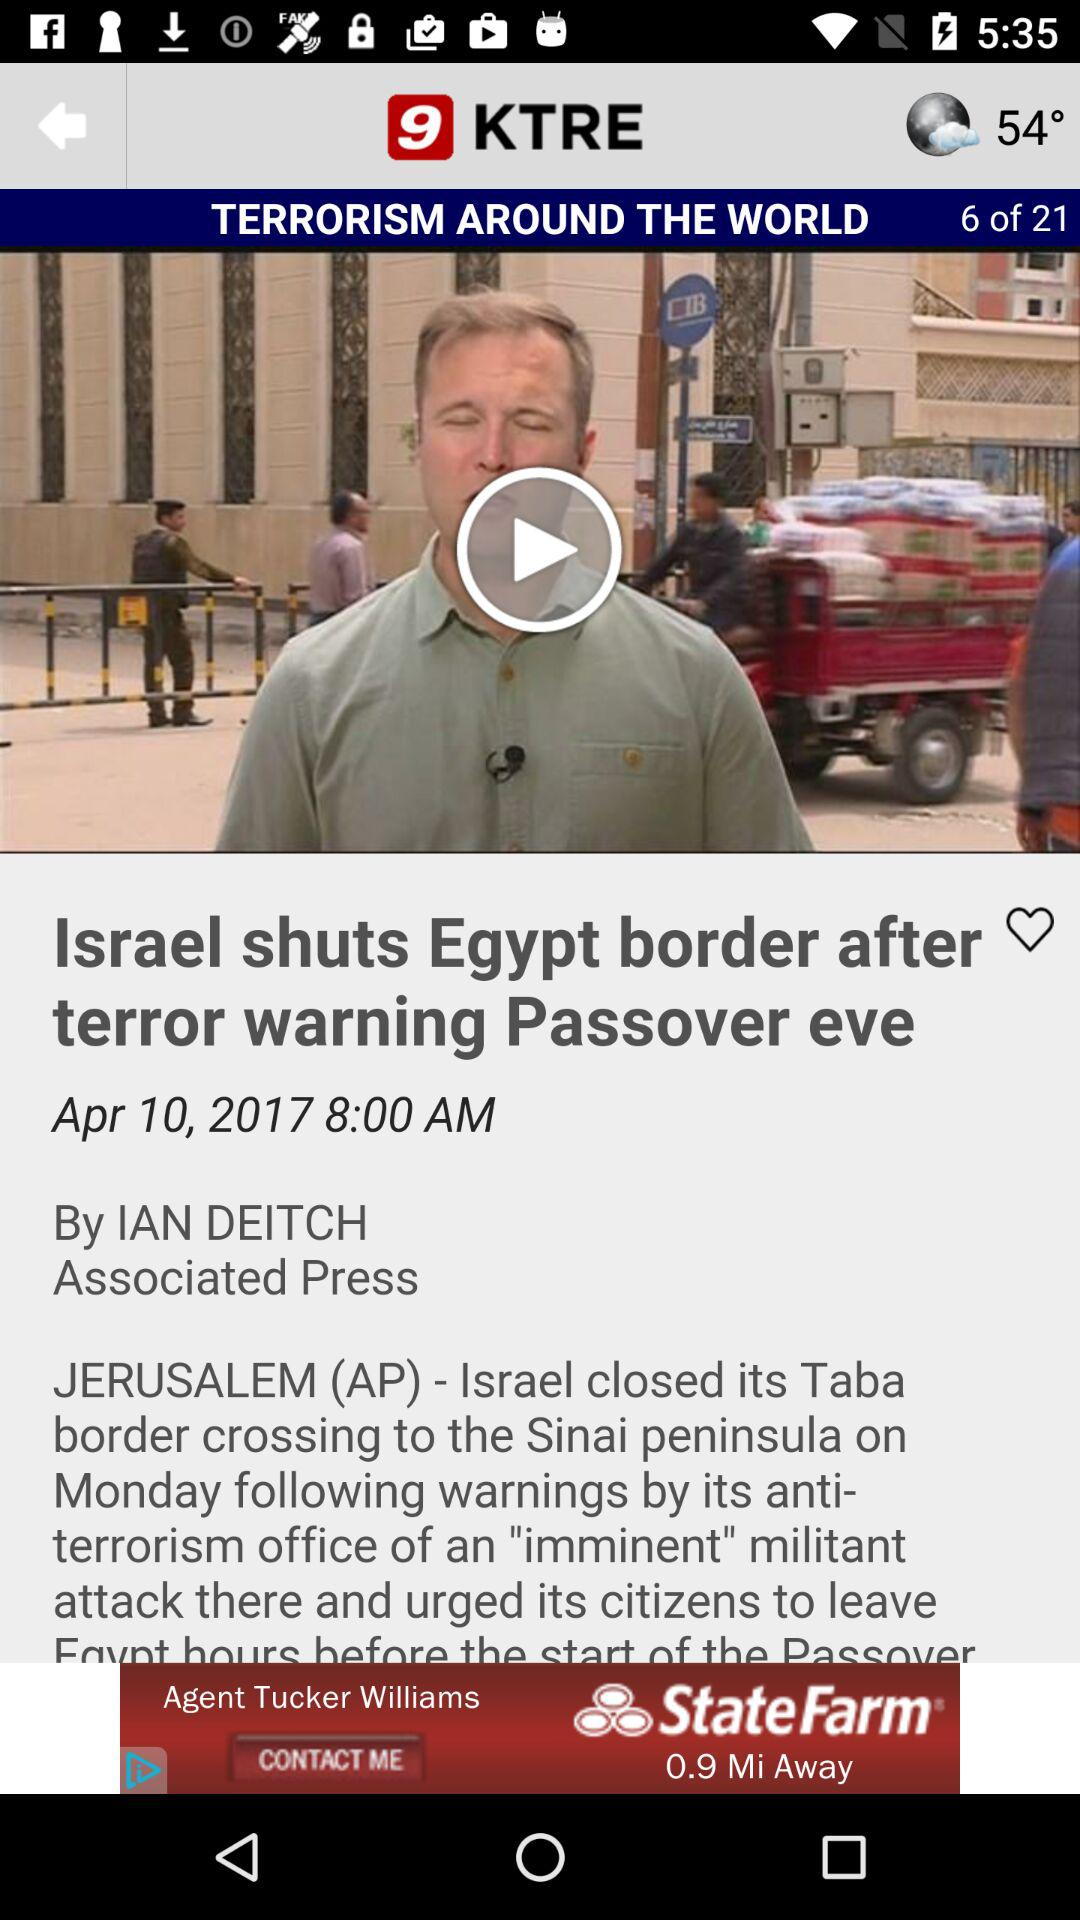What is the headline of the news? The headline of the news is "Israel shuts Egypt border after terror warning Passover eve". 